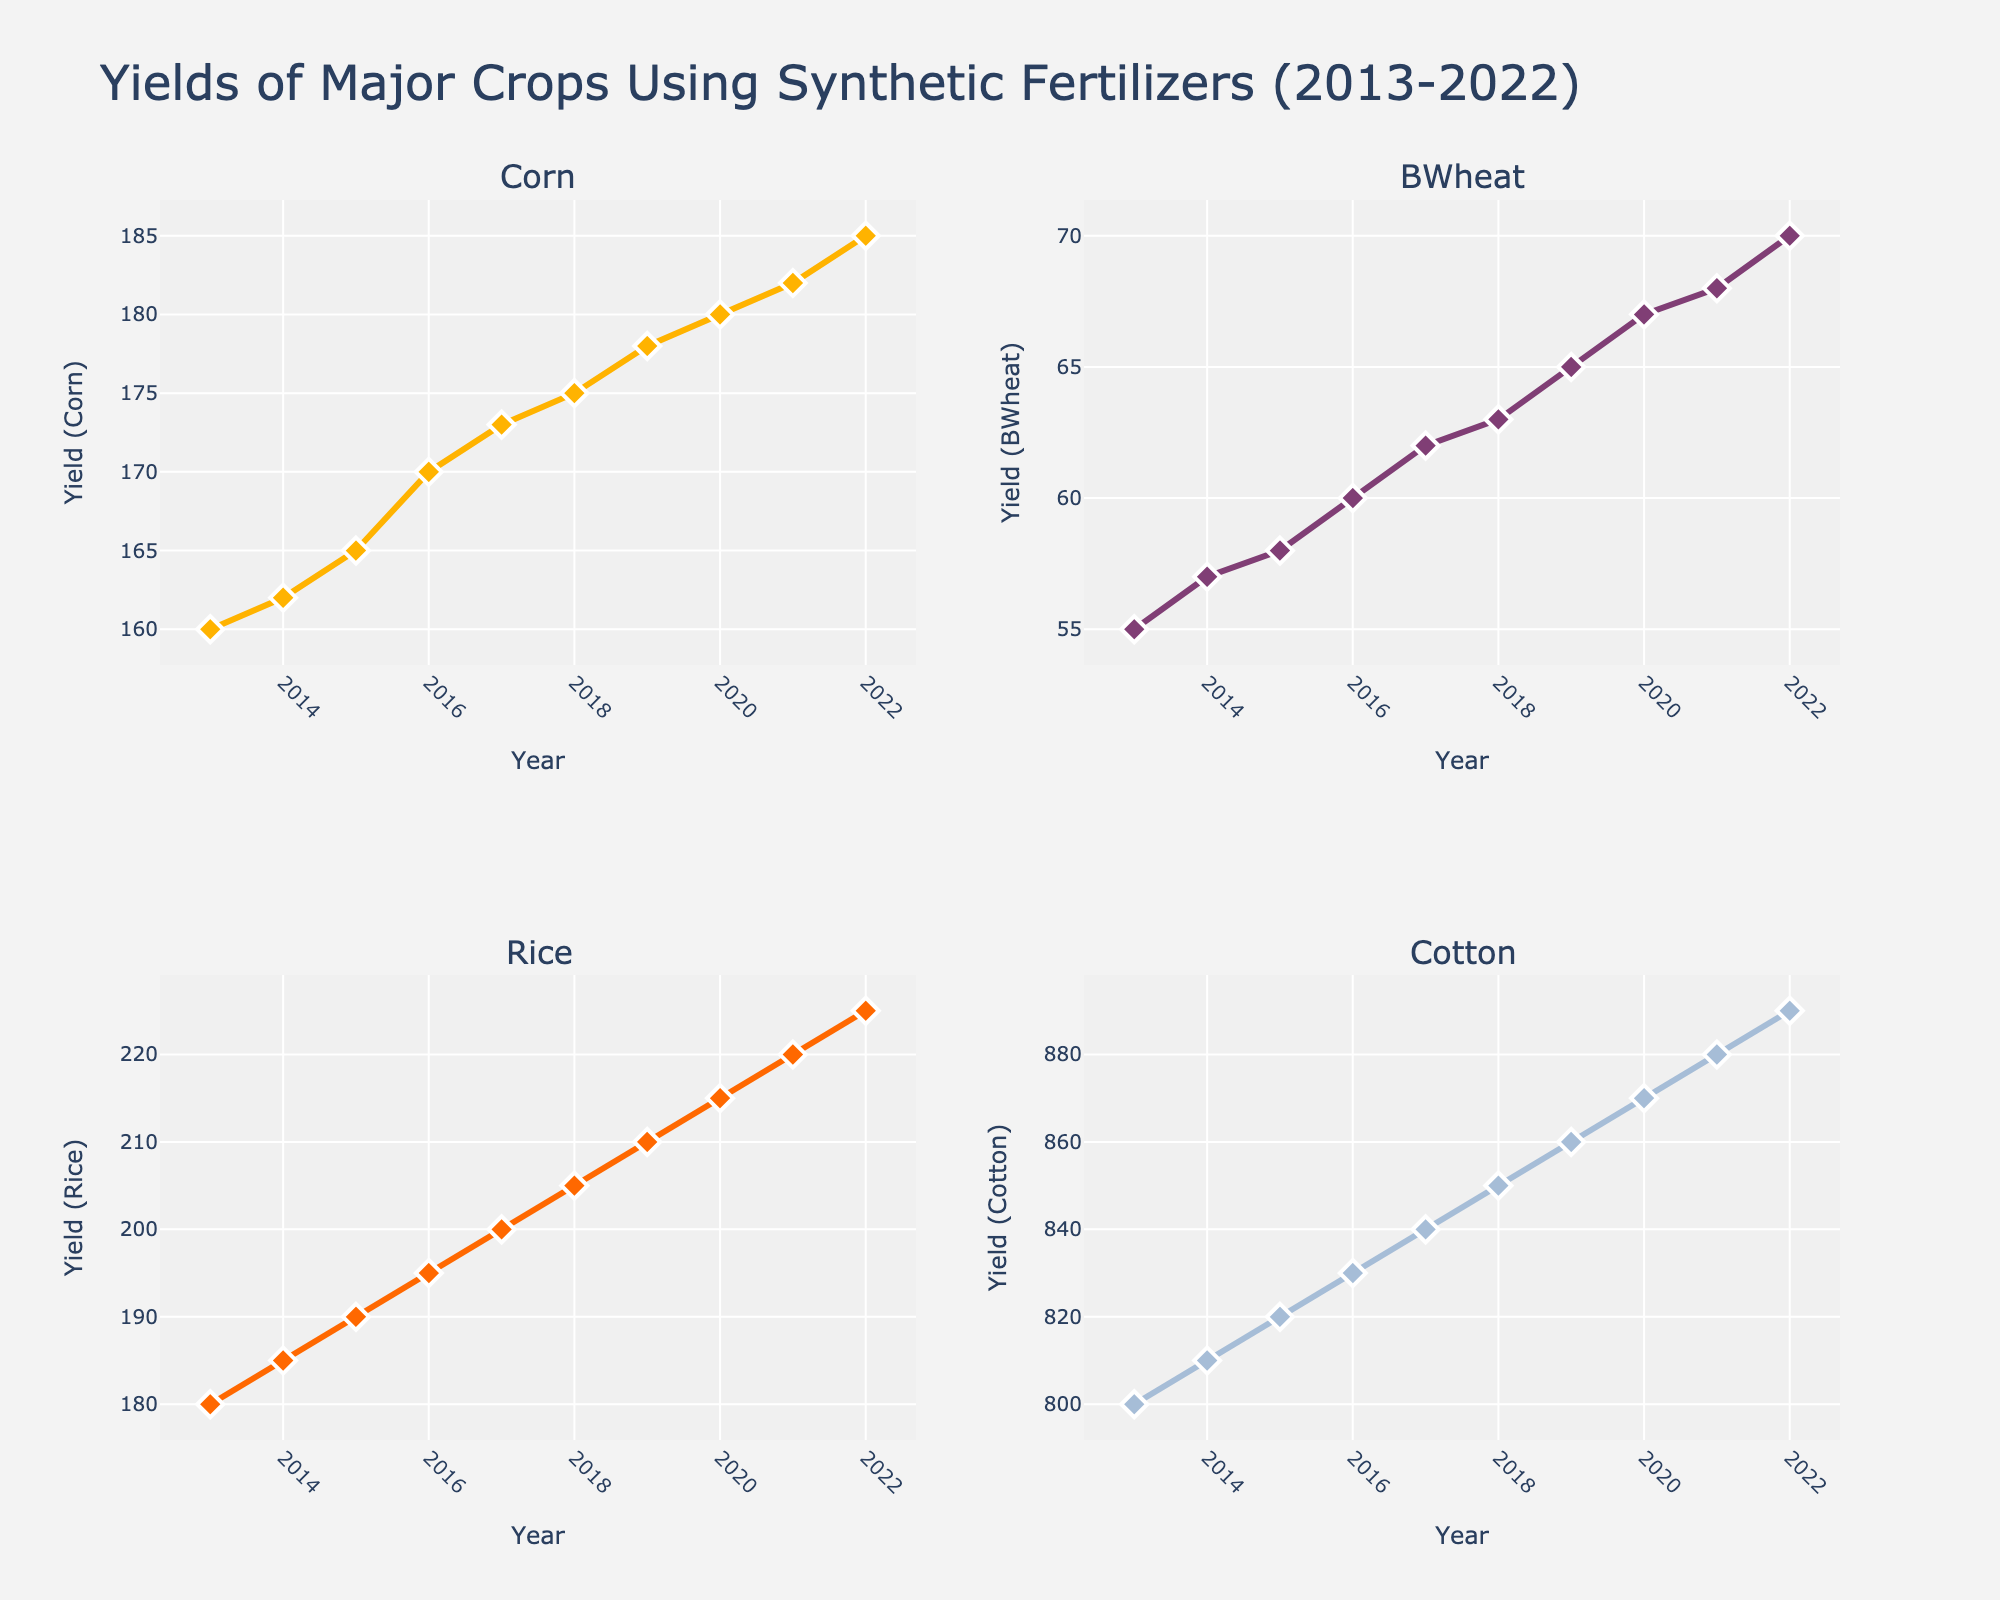what is the title of the figure? The title of the figure is usually at the top of a plot and gives an overview of what the plot is about. In this case, it reads "Yields of Major Crops Using Synthetic Fertilizers (2013-2022)".
Answer: Yields of Major Crops Using Synthetic Fertilizers (2013-2022) what are the four crops displayed in the figure? The subplot titles indicate the crops being shown. Here, the subplot titles are 'Corn', 'BWheat', 'Rice', and 'Cotton'.
Answer: Corn, BWheat, Rice, Cotton which crop shows the highest yield in 2022? By comparing the yields of all crops in 2022 across the subplots, the highest yield is for Cotton, with a value of 890.
Answer: Cotton What is the average yield for Barley over the past decade? To find the average yield for Barley, add the values from 2013 to 2022 and divide by the number of years. The values are 55, 57, 58, 60, 62, 63, 65, 67, 68, 70. Sum = 625. Average = 625/10 = 62.5
Answer: 62.5 In which year does Corn show the most significant increase in yield compared to the previous year? Calculate the difference in yield between subsequent years for Corn and identify the maximum increase. The largest increase is between 2015 and 2016 (170-165 = 5).
Answer: 2016 What is the trend in Rice yield from 2013 to 2022? Observing the subplot for Rice, it shows a consistent upward trend in yield from 180 in 2013 to 225 in 2022.
Answer: Upward Which crop had the smallest yield increase over the decade? By comparing yield changes from 2013 to 2022 for each crop: Corn (185 - 160 = 25), Barley (70 - 55 = 15), Rice (225 - 180 = 45), Cotton (890 - 800 = 90), Barley had the smallest increase with a rise of just 15 units.
Answer: Barley How does Cotton yield growth compare to Corn yield growth over the past decade? Calculate yield growth for both; Corn increases from 160 to 185 (25 units), Cotton increases from 800 to 890 (90 units). Compare the values: Cotton has a higher overall increase.
Answer: Cotton yield growth is higher Which crop yields reached their peak in the most recent year, 2022? All crops' yields in 2022: Corn (185), Barley (70), Rice (225), Cotton (890). All crops reached their peak values in 2022 as it is the most recent data point.
Answer: All crops 